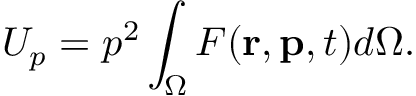<formula> <loc_0><loc_0><loc_500><loc_500>U _ { p } = p ^ { 2 } \int _ { \Omega } F ( r , p , t ) d \Omega .</formula> 